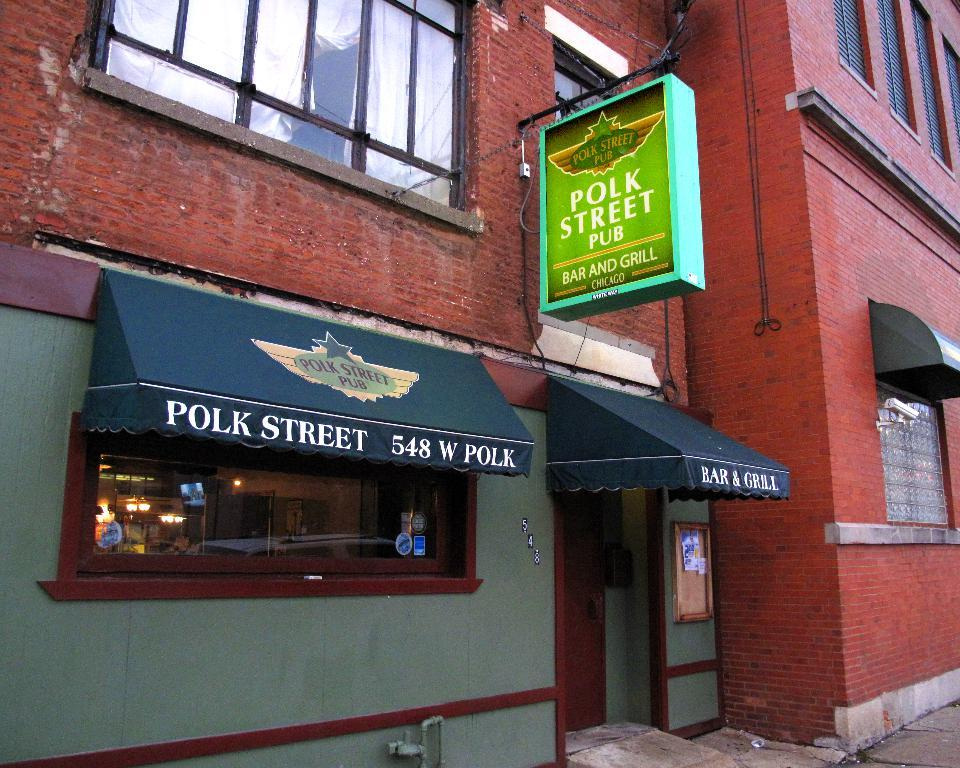What type of structure is in the image? There is a building in the image. What features can be seen on the building? The building has windows and a door. What is attached to the building? There is a board with text in the image. What can be seen through the glass in the image? Some objects are visible through the glass in the image. How many tomatoes are on the sister's plate in the image? There is no mention of tomatoes, a plate, or a sister in the image. 